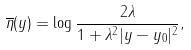<formula> <loc_0><loc_0><loc_500><loc_500>\overline { \eta } ( y ) = \log \frac { 2 \lambda } { 1 + \lambda ^ { 2 } | y - y _ { 0 } | ^ { 2 } } ,</formula> 